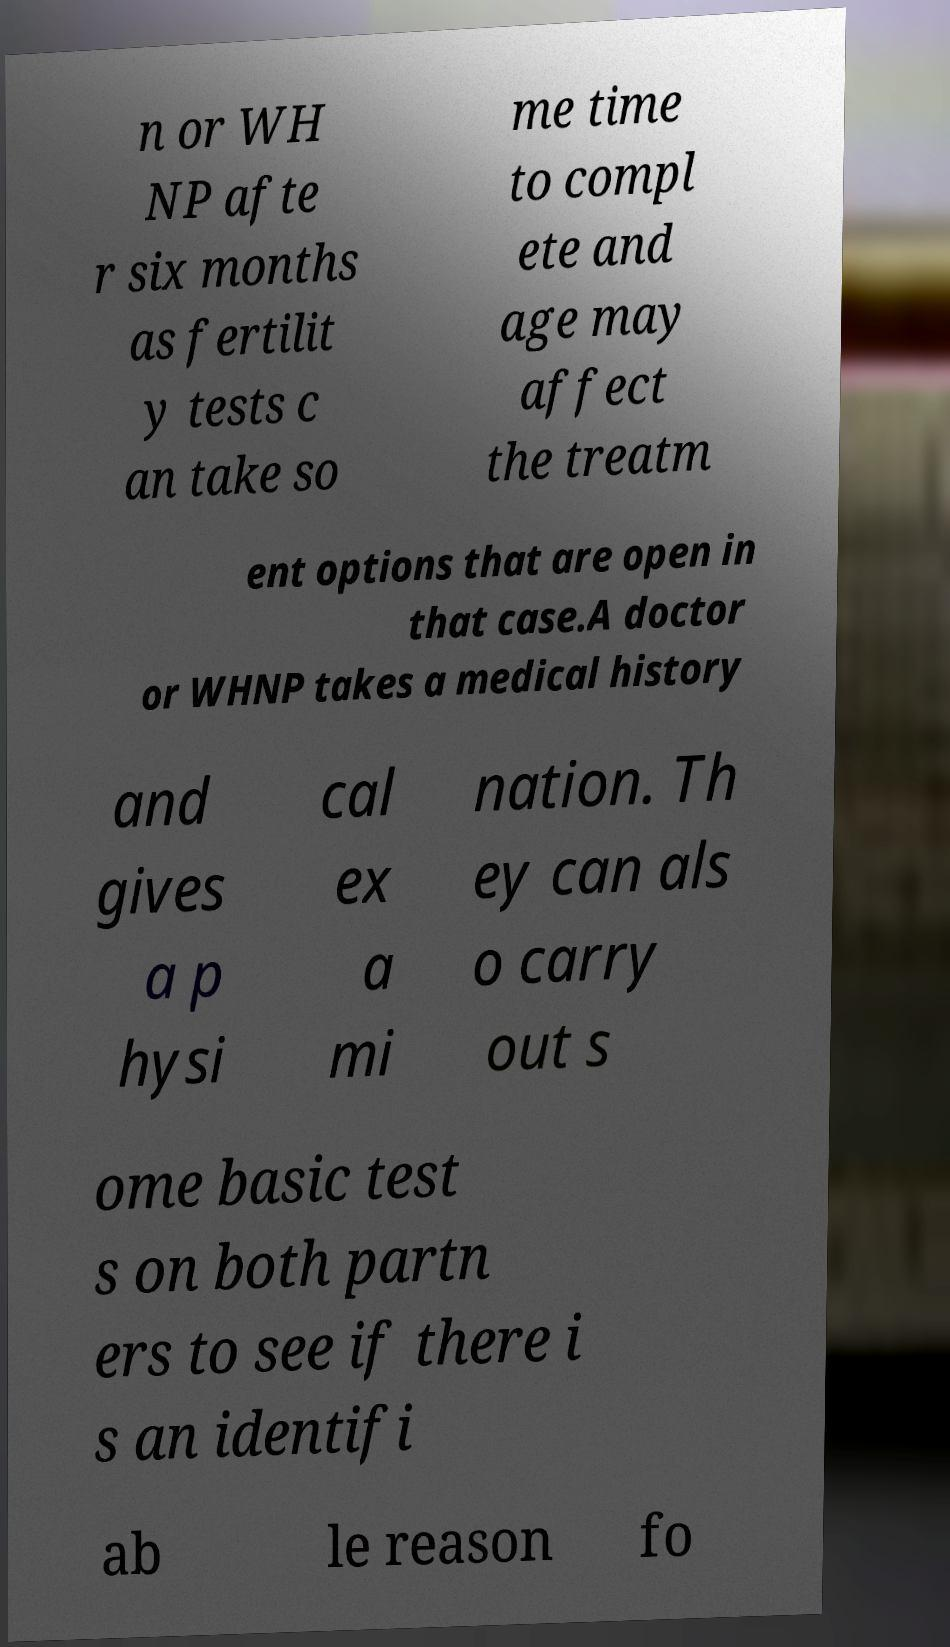There's text embedded in this image that I need extracted. Can you transcribe it verbatim? n or WH NP afte r six months as fertilit y tests c an take so me time to compl ete and age may affect the treatm ent options that are open in that case.A doctor or WHNP takes a medical history and gives a p hysi cal ex a mi nation. Th ey can als o carry out s ome basic test s on both partn ers to see if there i s an identifi ab le reason fo 